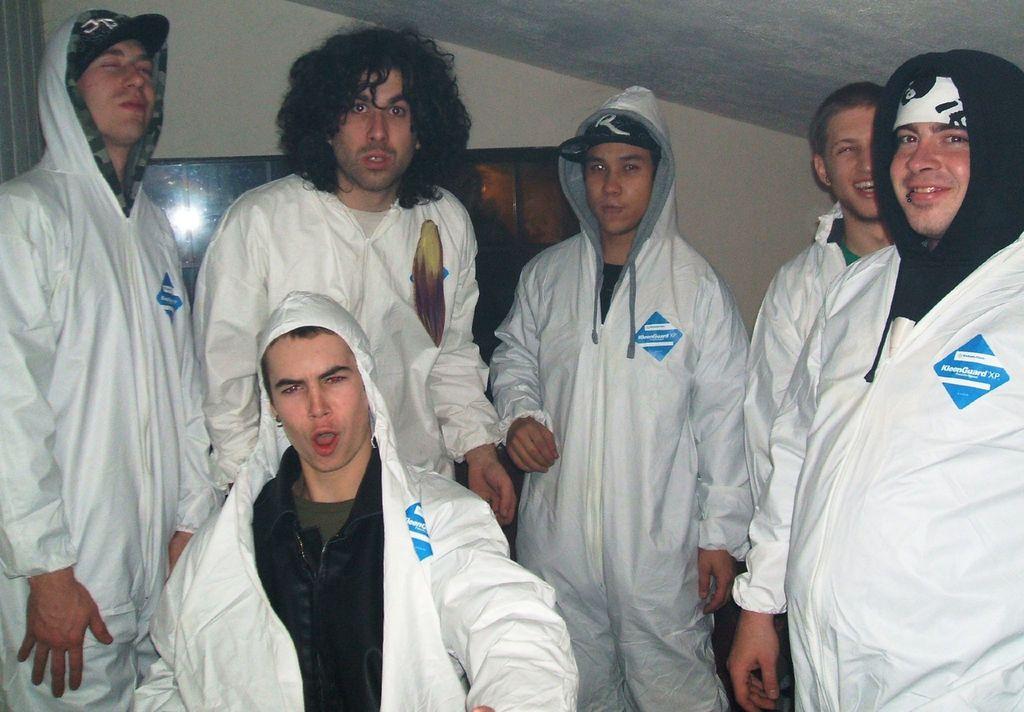What kind of guard is on labeled in the blue diamond?
Offer a very short reply. Kleenguard xp. 